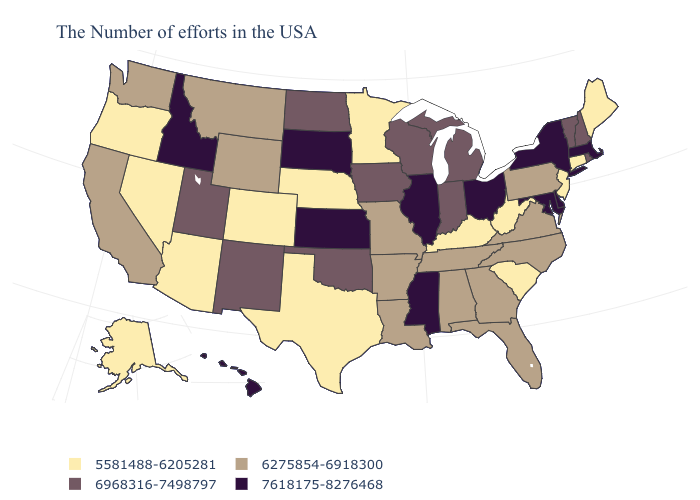Does the first symbol in the legend represent the smallest category?
Be succinct. Yes. What is the value of Arizona?
Short answer required. 5581488-6205281. Name the states that have a value in the range 6968316-7498797?
Keep it brief. Rhode Island, New Hampshire, Vermont, Michigan, Indiana, Wisconsin, Iowa, Oklahoma, North Dakota, New Mexico, Utah. Does Ohio have the highest value in the USA?
Concise answer only. Yes. Name the states that have a value in the range 7618175-8276468?
Give a very brief answer. Massachusetts, New York, Delaware, Maryland, Ohio, Illinois, Mississippi, Kansas, South Dakota, Idaho, Hawaii. Does Vermont have the lowest value in the USA?
Quick response, please. No. Does Connecticut have the lowest value in the USA?
Short answer required. Yes. Is the legend a continuous bar?
Keep it brief. No. Does Virginia have a higher value than Wyoming?
Be succinct. No. Among the states that border Delaware , which have the lowest value?
Short answer required. New Jersey. What is the lowest value in the Northeast?
Be succinct. 5581488-6205281. Does Wyoming have a lower value than California?
Be succinct. No. What is the value of South Carolina?
Give a very brief answer. 5581488-6205281. What is the value of Oregon?
Answer briefly. 5581488-6205281. Name the states that have a value in the range 6968316-7498797?
Write a very short answer. Rhode Island, New Hampshire, Vermont, Michigan, Indiana, Wisconsin, Iowa, Oklahoma, North Dakota, New Mexico, Utah. 